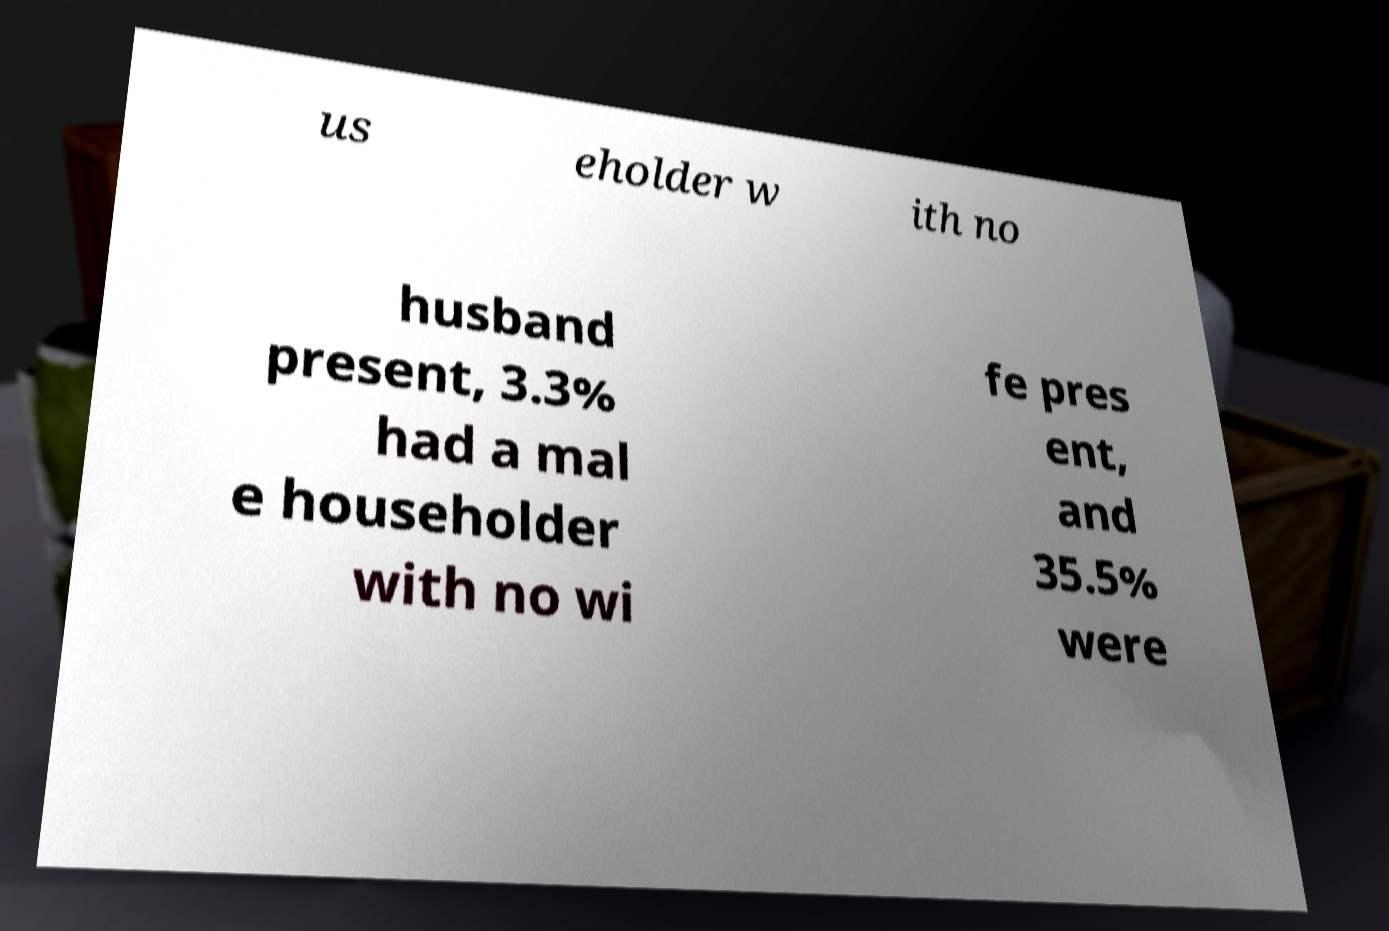For documentation purposes, I need the text within this image transcribed. Could you provide that? us eholder w ith no husband present, 3.3% had a mal e householder with no wi fe pres ent, and 35.5% were 